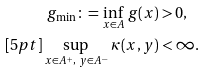Convert formula to latex. <formula><loc_0><loc_0><loc_500><loc_500>g _ { \min } \colon = \inf _ { x \in A } \, g ( x ) & > 0 , \\ [ 5 p t ] \sup _ { x \in A ^ { + } , \ y \in A ^ { - } } \, \kappa ( x , y ) & < \infty .</formula> 